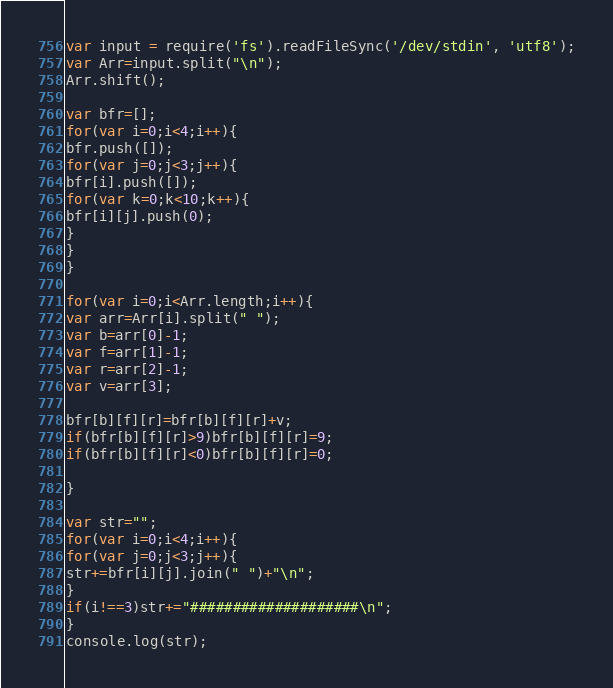Convert code to text. <code><loc_0><loc_0><loc_500><loc_500><_JavaScript_>var input = require('fs').readFileSync('/dev/stdin', 'utf8');
var Arr=input.split("\n");
Arr.shift();

var bfr=[];
for(var i=0;i<4;i++){
bfr.push([]);
for(var j=0;j<3;j++){
bfr[i].push([]);
for(var k=0;k<10;k++){
bfr[i][j].push(0);
}
}
}

for(var i=0;i<Arr.length;i++){
var arr=Arr[i].split(" ");
var b=arr[0]-1;
var f=arr[1]-1;
var r=arr[2]-1;
var v=arr[3];

bfr[b][f][r]=bfr[b][f][r]+v;
if(bfr[b][f][r]>9)bfr[b][f][r]=9;
if(bfr[b][f][r]<0)bfr[b][f][r]=0;

}

var str="";
for(var i=0;i<4;i++){
for(var j=0;j<3;j++){
str+=bfr[i][j].join(" ")+"\n";
}
if(i!==3)str+="####################\n";
}
console.log(str);</code> 